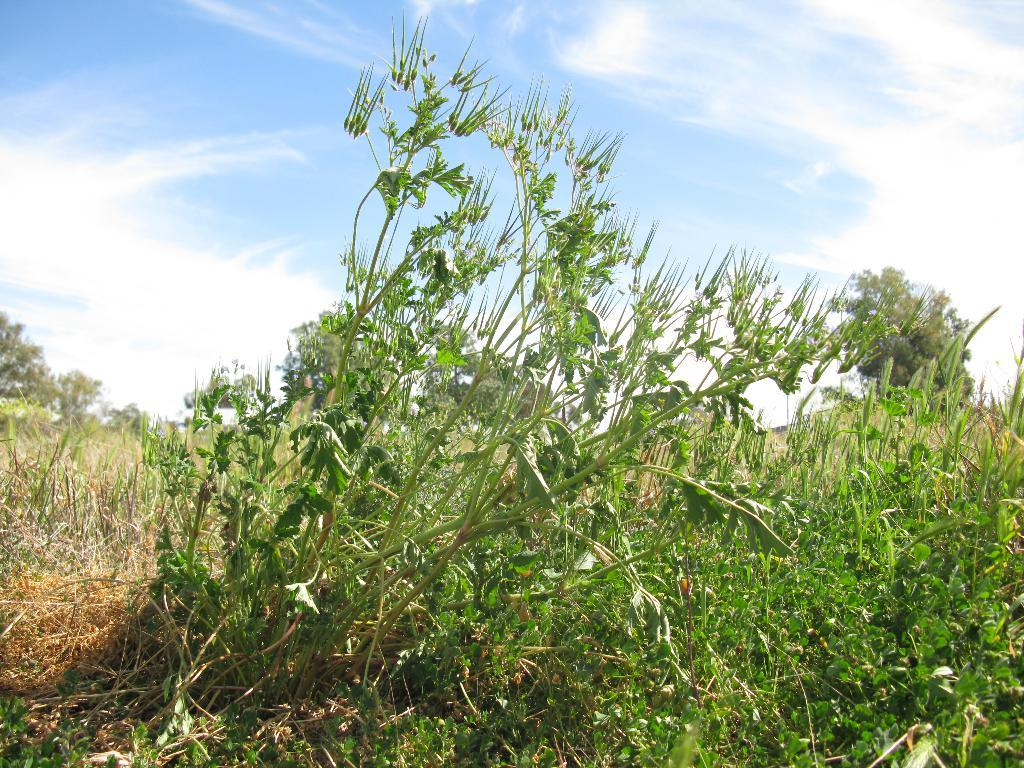What is the location of the image in relation to the city? The image is taken from outside the city. What type of vegetation can be seen in the image? There are plants and trees in the image. What is visible in the background of the image? The sky is visible in the image. What is the weather like in the image? The sky is cloudy in the image. Can you see a lake in the image? There is no lake present in the image. What type of ball is being used by the people in the image? There are no people or balls visible in the image. 